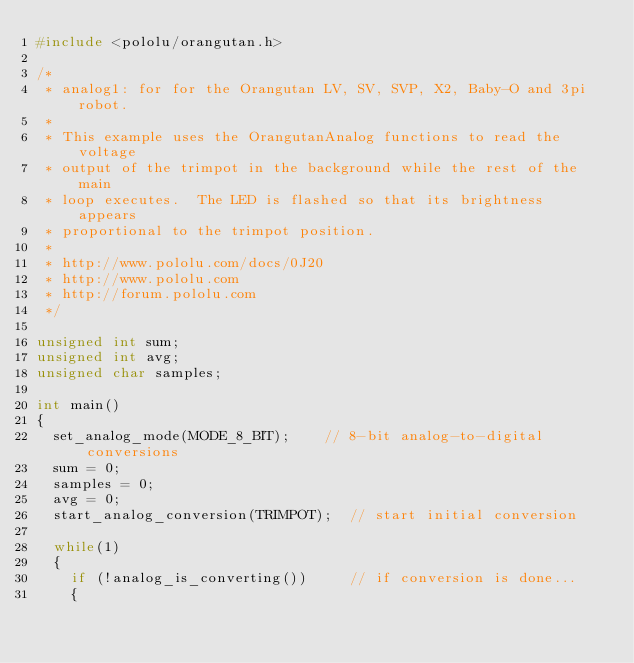<code> <loc_0><loc_0><loc_500><loc_500><_C_>#include <pololu/orangutan.h>

/*
 * analog1: for for the Orangutan LV, SV, SVP, X2, Baby-O and 3pi robot.
 *
 * This example uses the OrangutanAnalog functions to read the voltage
 * output of the trimpot in the background while the rest of the main
 * loop executes.  The LED is flashed so that its brightness appears
 * proportional to the trimpot position.
 *
 * http://www.pololu.com/docs/0J20
 * http://www.pololu.com
 * http://forum.pololu.com
 */

unsigned int sum;
unsigned int avg;
unsigned char samples;

int main()
{
  set_analog_mode(MODE_8_BIT);    // 8-bit analog-to-digital conversions
  sum = 0;
  samples = 0;
  avg = 0;
  start_analog_conversion(TRIMPOT);  // start initial conversion

  while(1)
  {
    if (!analog_is_converting())     // if conversion is done...
    {</code> 